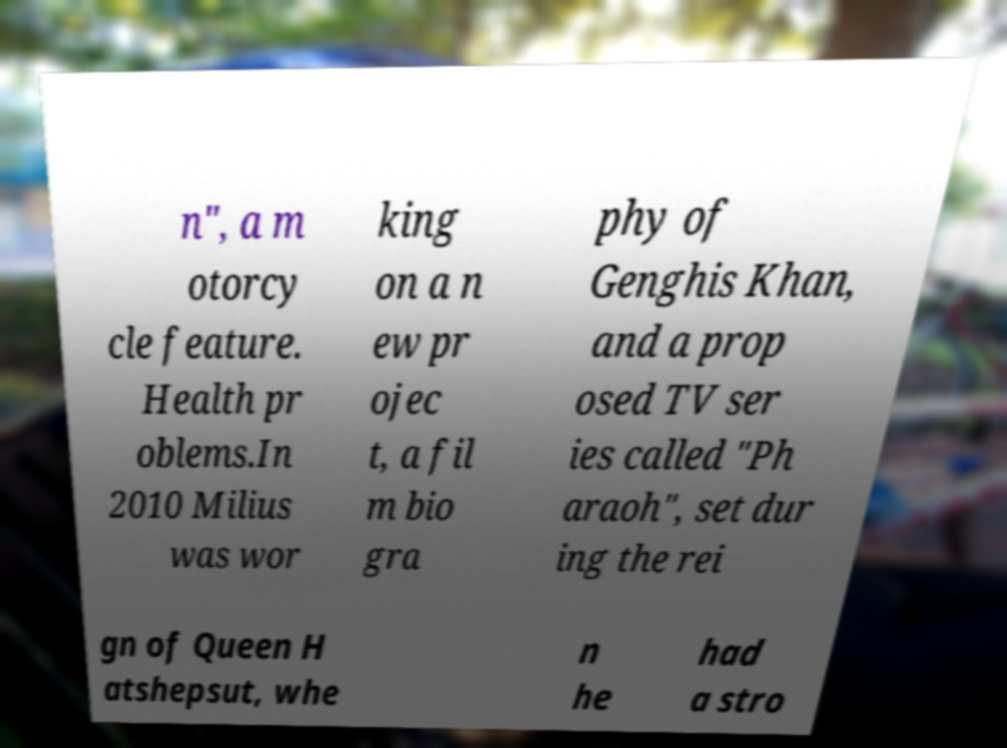Could you extract and type out the text from this image? n", a m otorcy cle feature. Health pr oblems.In 2010 Milius was wor king on a n ew pr ojec t, a fil m bio gra phy of Genghis Khan, and a prop osed TV ser ies called "Ph araoh", set dur ing the rei gn of Queen H atshepsut, whe n he had a stro 